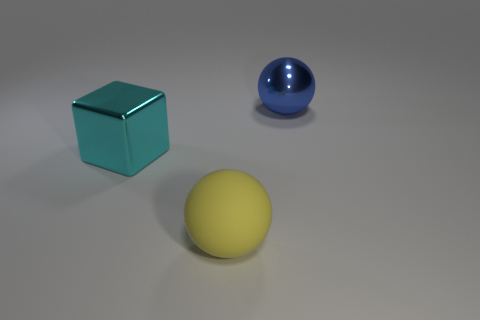What is the color of the other big matte thing that is the same shape as the blue object?
Your answer should be very brief. Yellow. Is the material of the large object behind the large cyan thing the same as the cyan thing?
Offer a very short reply. Yes. How many big objects are either yellow rubber things or purple rubber spheres?
Offer a very short reply. 1. The cyan object is what size?
Provide a short and direct response. Large. Do the cyan shiny thing and the shiny thing that is on the right side of the big yellow ball have the same size?
Keep it short and to the point. Yes. How many purple objects are big matte things or metallic objects?
Your response must be concise. 0. What number of blue objects are there?
Provide a succinct answer. 1. Do the block and the blue metal thing have the same size?
Your answer should be compact. Yes. What number of things are either large things or balls that are behind the big matte thing?
Offer a terse response. 3. What is the big blue thing made of?
Provide a succinct answer. Metal. 